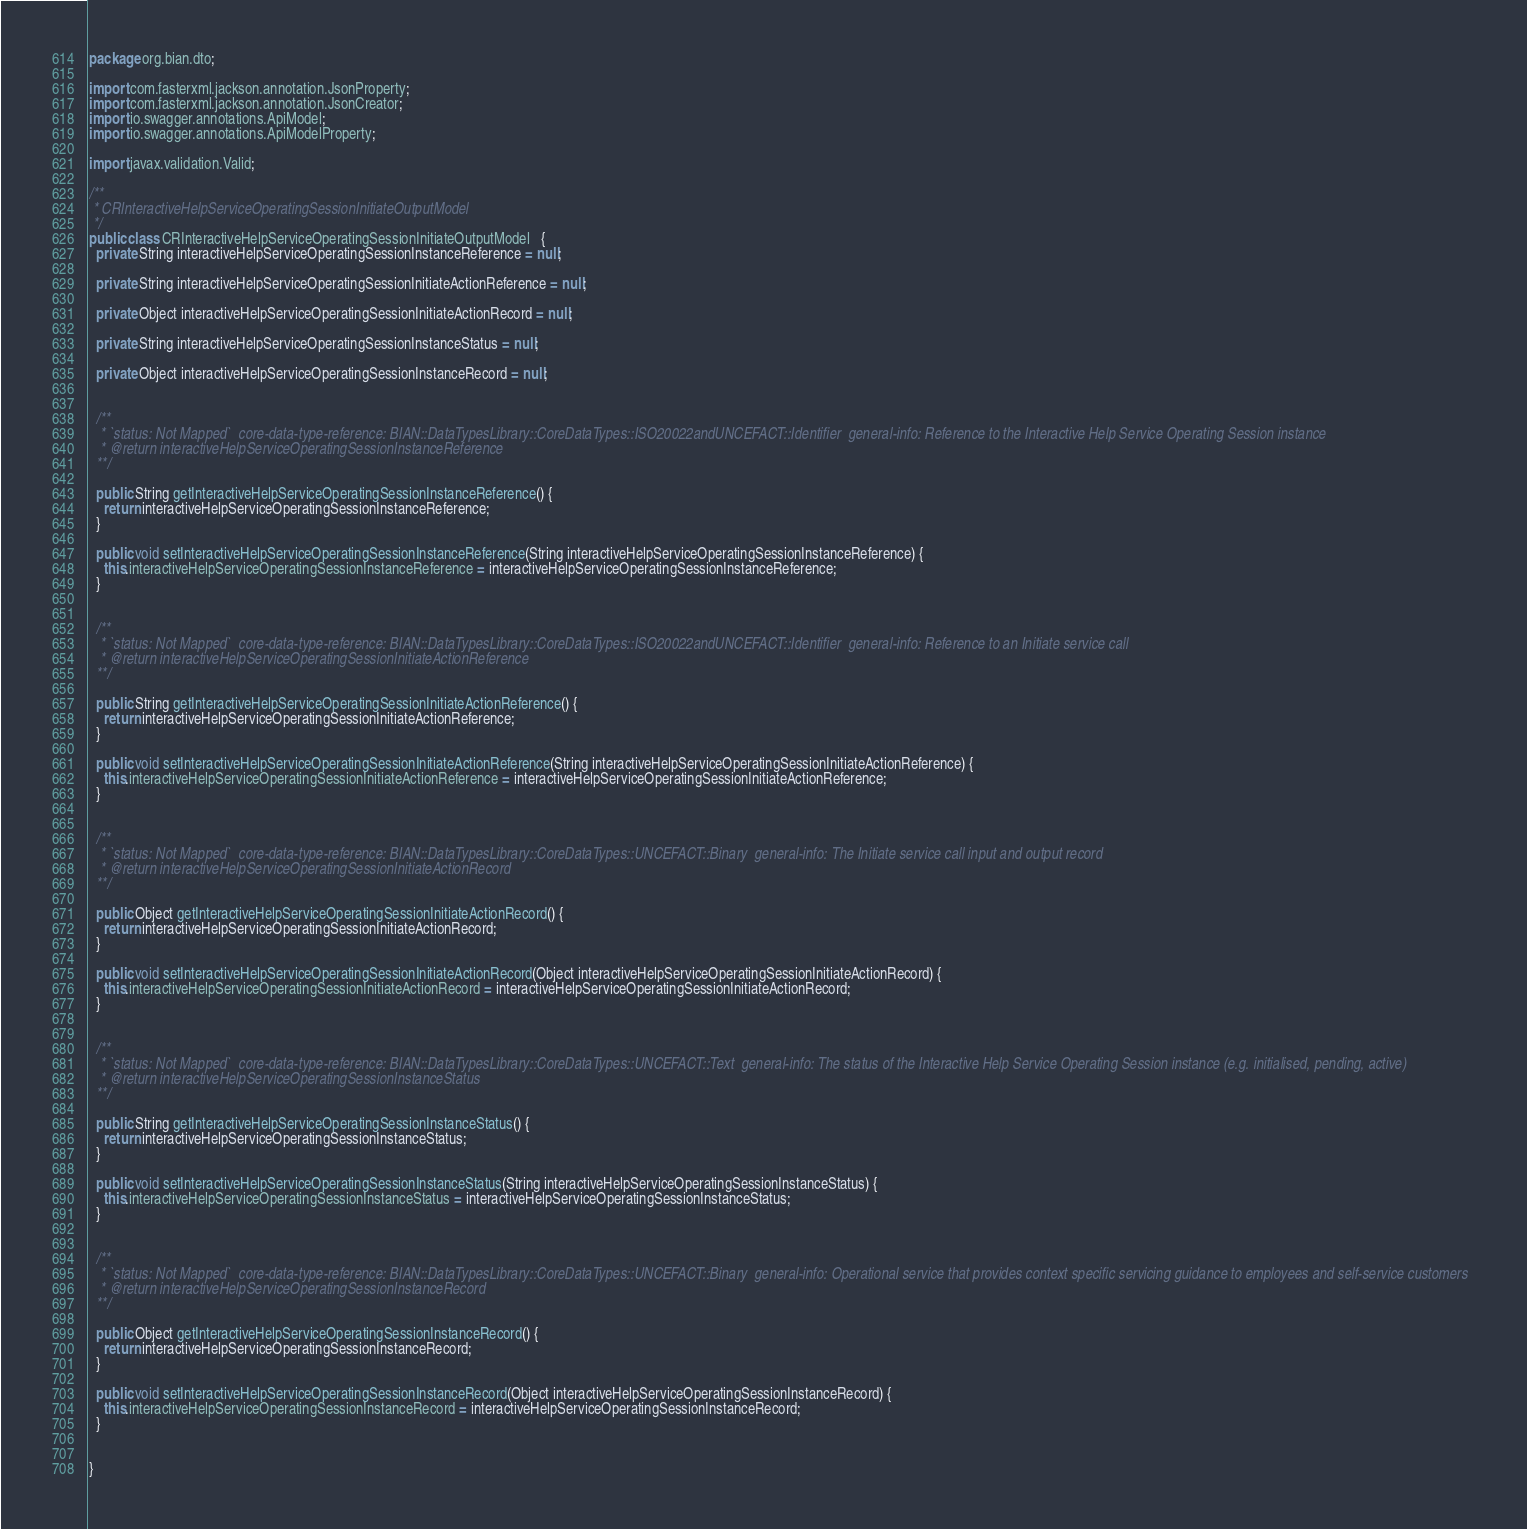<code> <loc_0><loc_0><loc_500><loc_500><_Java_>package org.bian.dto;

import com.fasterxml.jackson.annotation.JsonProperty;
import com.fasterxml.jackson.annotation.JsonCreator;
import io.swagger.annotations.ApiModel;
import io.swagger.annotations.ApiModelProperty;

import javax.validation.Valid;
  
/**
 * CRInteractiveHelpServiceOperatingSessionInitiateOutputModel
 */
public class CRInteractiveHelpServiceOperatingSessionInitiateOutputModel   {
  private String interactiveHelpServiceOperatingSessionInstanceReference = null;

  private String interactiveHelpServiceOperatingSessionInitiateActionReference = null;

  private Object interactiveHelpServiceOperatingSessionInitiateActionRecord = null;

  private String interactiveHelpServiceOperatingSessionInstanceStatus = null;

  private Object interactiveHelpServiceOperatingSessionInstanceRecord = null;


  /**
   * `status: Not Mapped`  core-data-type-reference: BIAN::DataTypesLibrary::CoreDataTypes::ISO20022andUNCEFACT::Identifier  general-info: Reference to the Interactive Help Service Operating Session instance 
   * @return interactiveHelpServiceOperatingSessionInstanceReference
  **/

  public String getInteractiveHelpServiceOperatingSessionInstanceReference() {
    return interactiveHelpServiceOperatingSessionInstanceReference;
  }

  public void setInteractiveHelpServiceOperatingSessionInstanceReference(String interactiveHelpServiceOperatingSessionInstanceReference) {
    this.interactiveHelpServiceOperatingSessionInstanceReference = interactiveHelpServiceOperatingSessionInstanceReference;
  }


  /**
   * `status: Not Mapped`  core-data-type-reference: BIAN::DataTypesLibrary::CoreDataTypes::ISO20022andUNCEFACT::Identifier  general-info: Reference to an Initiate service call 
   * @return interactiveHelpServiceOperatingSessionInitiateActionReference
  **/

  public String getInteractiveHelpServiceOperatingSessionInitiateActionReference() {
    return interactiveHelpServiceOperatingSessionInitiateActionReference;
  }

  public void setInteractiveHelpServiceOperatingSessionInitiateActionReference(String interactiveHelpServiceOperatingSessionInitiateActionReference) {
    this.interactiveHelpServiceOperatingSessionInitiateActionReference = interactiveHelpServiceOperatingSessionInitiateActionReference;
  }


  /**
   * `status: Not Mapped`  core-data-type-reference: BIAN::DataTypesLibrary::CoreDataTypes::UNCEFACT::Binary  general-info: The Initiate service call input and output record 
   * @return interactiveHelpServiceOperatingSessionInitiateActionRecord
  **/

  public Object getInteractiveHelpServiceOperatingSessionInitiateActionRecord() {
    return interactiveHelpServiceOperatingSessionInitiateActionRecord;
  }

  public void setInteractiveHelpServiceOperatingSessionInitiateActionRecord(Object interactiveHelpServiceOperatingSessionInitiateActionRecord) {
    this.interactiveHelpServiceOperatingSessionInitiateActionRecord = interactiveHelpServiceOperatingSessionInitiateActionRecord;
  }


  /**
   * `status: Not Mapped`  core-data-type-reference: BIAN::DataTypesLibrary::CoreDataTypes::UNCEFACT::Text  general-info: The status of the Interactive Help Service Operating Session instance (e.g. initialised, pending, active) 
   * @return interactiveHelpServiceOperatingSessionInstanceStatus
  **/

  public String getInteractiveHelpServiceOperatingSessionInstanceStatus() {
    return interactiveHelpServiceOperatingSessionInstanceStatus;
  }

  public void setInteractiveHelpServiceOperatingSessionInstanceStatus(String interactiveHelpServiceOperatingSessionInstanceStatus) {
    this.interactiveHelpServiceOperatingSessionInstanceStatus = interactiveHelpServiceOperatingSessionInstanceStatus;
  }


  /**
   * `status: Not Mapped`  core-data-type-reference: BIAN::DataTypesLibrary::CoreDataTypes::UNCEFACT::Binary  general-info: Operational service that provides context specific servicing guidance to employees and self-service customers 
   * @return interactiveHelpServiceOperatingSessionInstanceRecord
  **/

  public Object getInteractiveHelpServiceOperatingSessionInstanceRecord() {
    return interactiveHelpServiceOperatingSessionInstanceRecord;
  }

  public void setInteractiveHelpServiceOperatingSessionInstanceRecord(Object interactiveHelpServiceOperatingSessionInstanceRecord) {
    this.interactiveHelpServiceOperatingSessionInstanceRecord = interactiveHelpServiceOperatingSessionInstanceRecord;
  }


}

</code> 